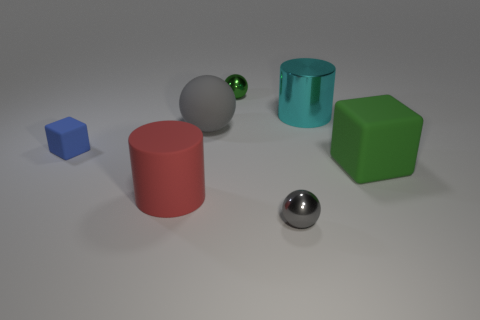How many other objects are there of the same size as the gray matte ball?
Offer a very short reply. 3. What is the color of the big metal object?
Ensure brevity in your answer.  Cyan. How many shiny things are balls or tiny green things?
Offer a very short reply. 2. Is there anything else that has the same material as the green cube?
Make the answer very short. Yes. There is a metal sphere that is in front of the big cylinder in front of the gray thing behind the green matte thing; what size is it?
Keep it short and to the point. Small. There is a sphere that is in front of the shiny cylinder and on the right side of the large gray sphere; what is its size?
Provide a succinct answer. Small. Does the small sphere in front of the red thing have the same color as the big matte thing behind the large cube?
Make the answer very short. Yes. There is a large red matte object; how many tiny blocks are in front of it?
Provide a succinct answer. 0. There is a rubber cube that is right of the matte cube that is left of the tiny gray object; are there any large things behind it?
Keep it short and to the point. Yes. How many green metallic balls have the same size as the gray metal object?
Offer a terse response. 1. 